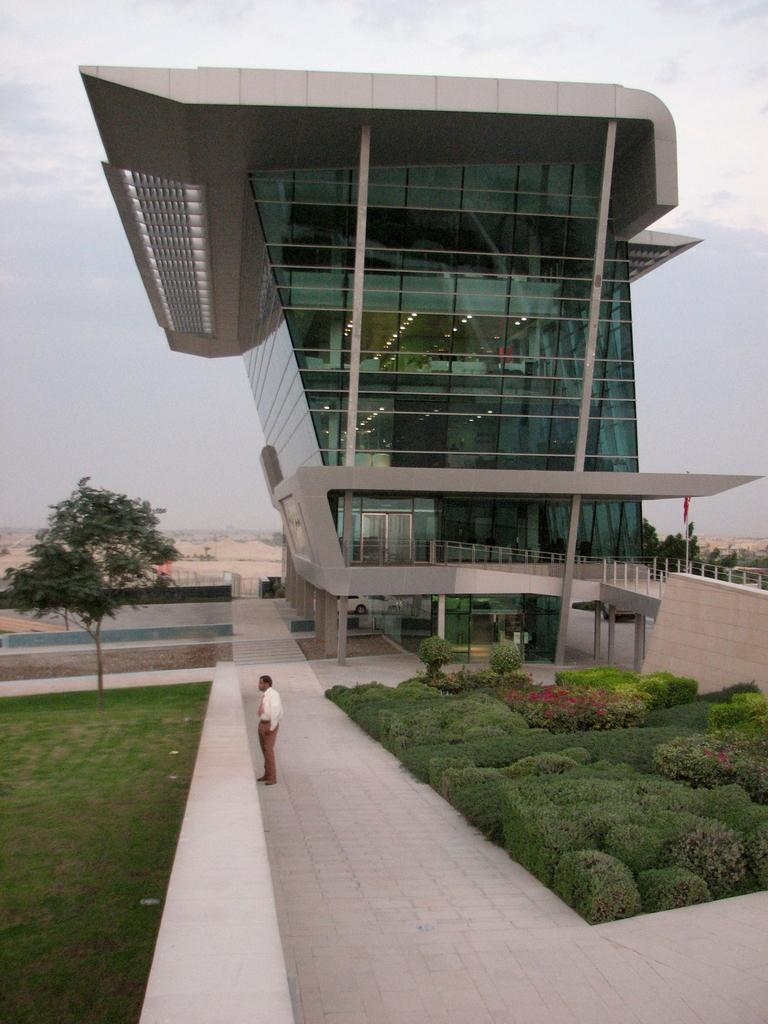What is the main subject of the image? There is a man standing in the image. What type of vegetation can be seen in the image? There are plants, grass, flowers, and trees in the image. What architectural features are present in the image? There are pillars, a building, and railings in the image. What part of the natural environment is visible in the image? The sky is visible in the background of the image. What type of brass instrument is the man playing in the image? There is no brass instrument present in the image; the man is simply standing. 